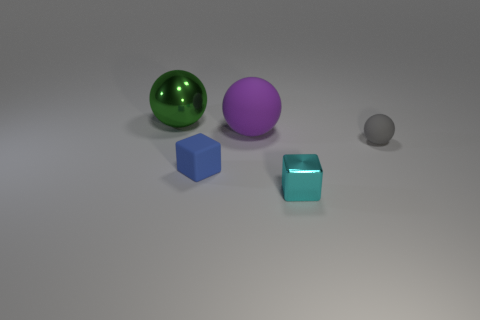Add 4 tiny cubes. How many objects exist? 9 Subtract all gray spheres. How many spheres are left? 2 Subtract all purple balls. How many balls are left? 2 Subtract all spheres. How many objects are left? 2 Subtract 2 spheres. How many spheres are left? 1 Subtract all big purple balls. Subtract all small green rubber cubes. How many objects are left? 4 Add 3 purple balls. How many purple balls are left? 4 Add 2 gray rubber objects. How many gray rubber objects exist? 3 Subtract 0 blue spheres. How many objects are left? 5 Subtract all purple spheres. Subtract all cyan cylinders. How many spheres are left? 2 